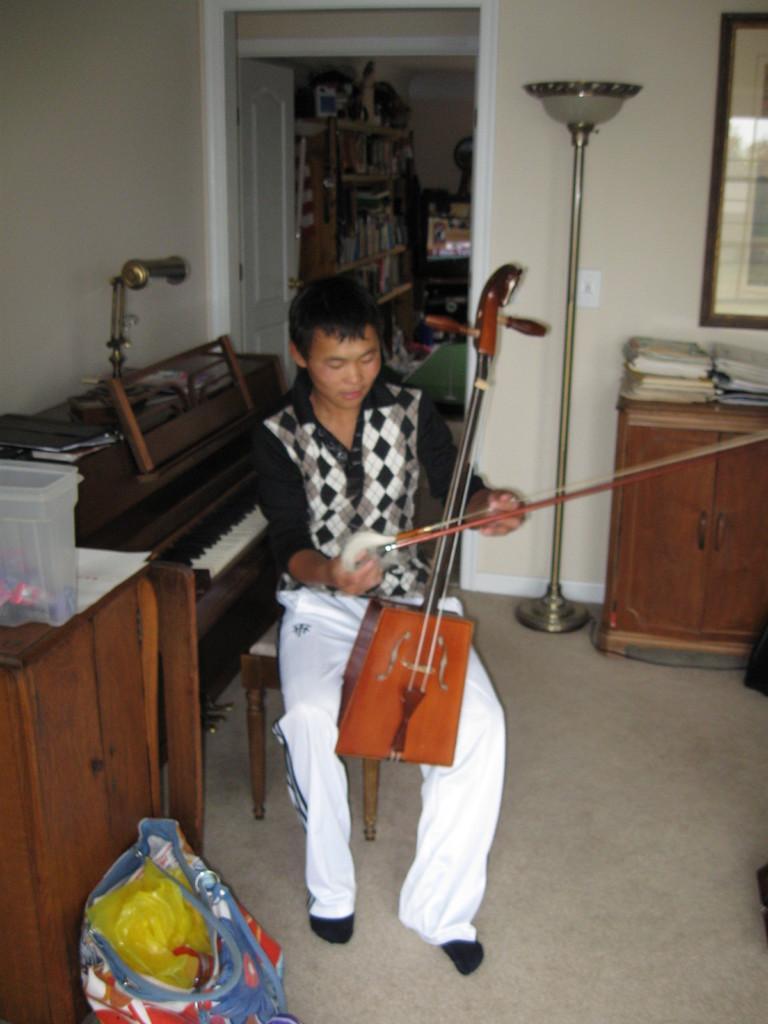How would you summarize this image in a sentence or two? This is an image clicked inside the room. In this image I can a person sitting on the stool and holding some musical instrument in his hands. On the left side of this image I can see a table and box on it. There is a blue color bag beside this table. At the back of this person there is a table and piano is placed on it. In the background I can see a door, rack some books are there in it and television. On the right side of this image there is another small table. On this table there are some books and papers. Above this table I can see a window. Beside this window there is a stand, on the top of it light is placed to it. 